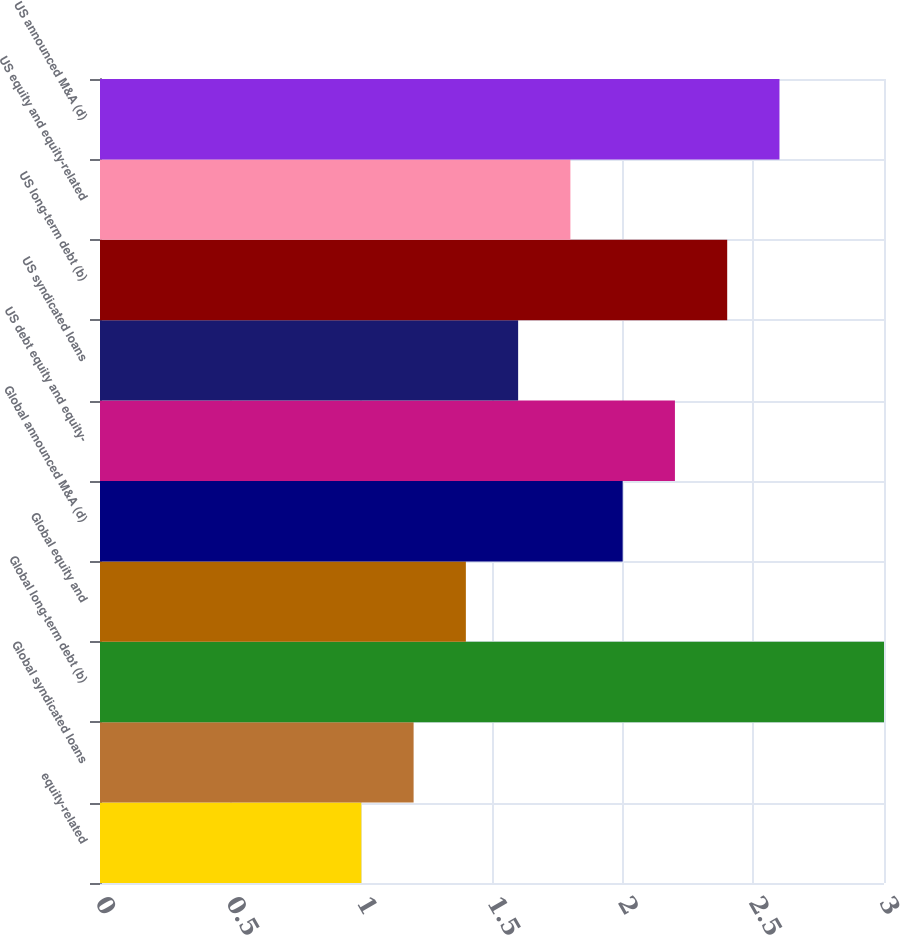<chart> <loc_0><loc_0><loc_500><loc_500><bar_chart><fcel>equity-related<fcel>Global syndicated loans<fcel>Global long-term debt (b)<fcel>Global equity and<fcel>Global announced M&A (d)<fcel>US debt equity and equity-<fcel>US syndicated loans<fcel>US long-term debt (b)<fcel>US equity and equity-related<fcel>US announced M&A (d)<nl><fcel>1<fcel>1.2<fcel>3<fcel>1.4<fcel>2<fcel>2.2<fcel>1.6<fcel>2.4<fcel>1.8<fcel>2.6<nl></chart> 